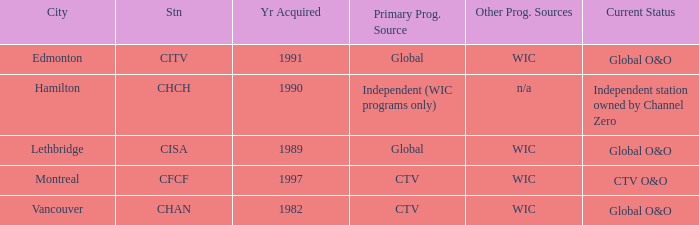Where is citv located Edmonton. 